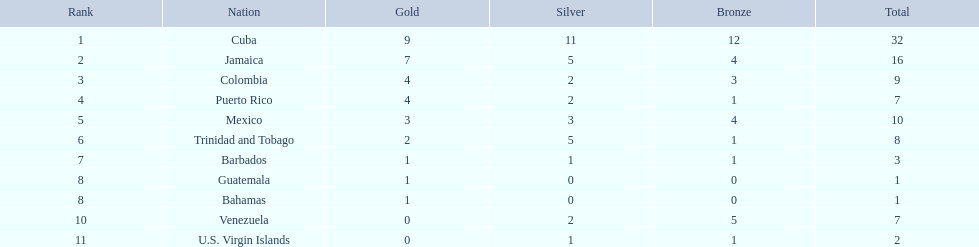Would you be able to parse every entry in this table? {'header': ['Rank', 'Nation', 'Gold', 'Silver', 'Bronze', 'Total'], 'rows': [['1', 'Cuba', '9', '11', '12', '32'], ['2', 'Jamaica', '7', '5', '4', '16'], ['3', 'Colombia', '4', '2', '3', '9'], ['4', 'Puerto Rico', '4', '2', '1', '7'], ['5', 'Mexico', '3', '3', '4', '10'], ['6', 'Trinidad and Tobago', '2', '5', '1', '8'], ['7', 'Barbados', '1', '1', '1', '3'], ['8', 'Guatemala', '1', '0', '0', '1'], ['8', 'Bahamas', '1', '0', '0', '1'], ['10', 'Venezuela', '0', '2', '5', '7'], ['11', 'U.S. Virgin Islands', '0', '1', '1', '2']]} Which teams obtained four gold medals? Colombia, Puerto Rico. Among them, which team secured only a single bronze medal? Puerto Rico. 